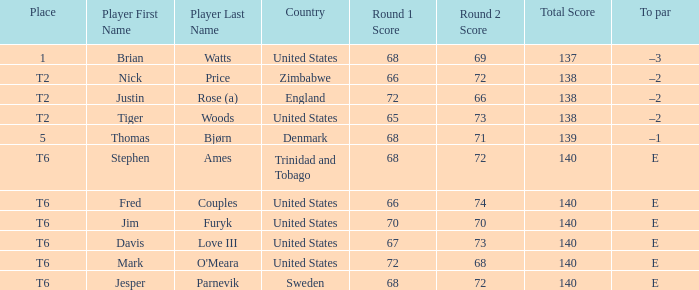What was the TO par for the player who scored 68-69=137? –3. Could you parse the entire table as a dict? {'header': ['Place', 'Player First Name', 'Player Last Name', 'Country', 'Round 1 Score', 'Round 2 Score', 'Total Score', 'To par'], 'rows': [['1', 'Brian', 'Watts', 'United States', '68', '69', '137', '–3'], ['T2', 'Nick', 'Price', 'Zimbabwe', '66', '72', '138', '–2'], ['T2', 'Justin', 'Rose (a)', 'England', '72', '66', '138', '–2'], ['T2', 'Tiger', 'Woods', 'United States', '65', '73', '138', '–2'], ['5', 'Thomas', 'Bjørn', 'Denmark', '68', '71', '139', '–1'], ['T6', 'Stephen', 'Ames', 'Trinidad and Tobago', '68', '72', '140', 'E'], ['T6', 'Fred', 'Couples', 'United States', '66', '74', '140', 'E'], ['T6', 'Jim', 'Furyk', 'United States', '70', '70', '140', 'E'], ['T6', 'Davis', 'Love III', 'United States', '67', '73', '140', 'E'], ['T6', 'Mark', "O'Meara", 'United States', '72', '68', '140', 'E'], ['T6', 'Jesper', 'Parnevik', 'Sweden', '68', '72', '140', 'E']]} 